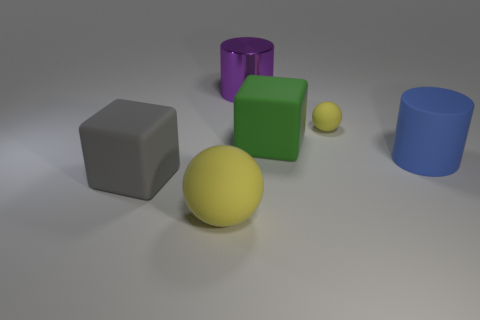Add 2 big yellow objects. How many objects exist? 8 Subtract all small objects. Subtract all purple cylinders. How many objects are left? 4 Add 5 tiny rubber balls. How many tiny rubber balls are left? 6 Add 6 large gray cubes. How many large gray cubes exist? 7 Subtract 1 yellow spheres. How many objects are left? 5 